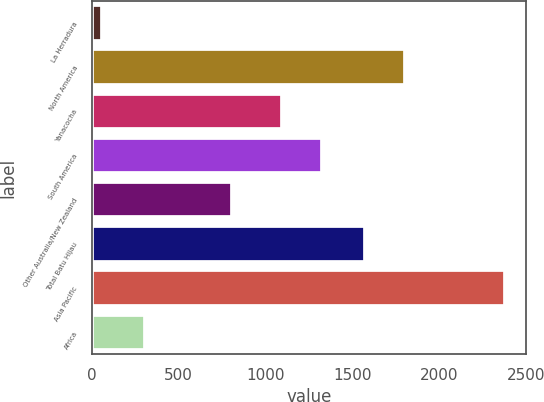Convert chart to OTSL. <chart><loc_0><loc_0><loc_500><loc_500><bar_chart><fcel>La Herradura<fcel>North America<fcel>Yanacocha<fcel>South America<fcel>Other Australia/New Zealand<fcel>Total Batu Hijau<fcel>Asia Pacific<fcel>Africa<nl><fcel>60<fcel>1804.1<fcel>1093<fcel>1325.1<fcel>809<fcel>1572<fcel>2381<fcel>306<nl></chart> 